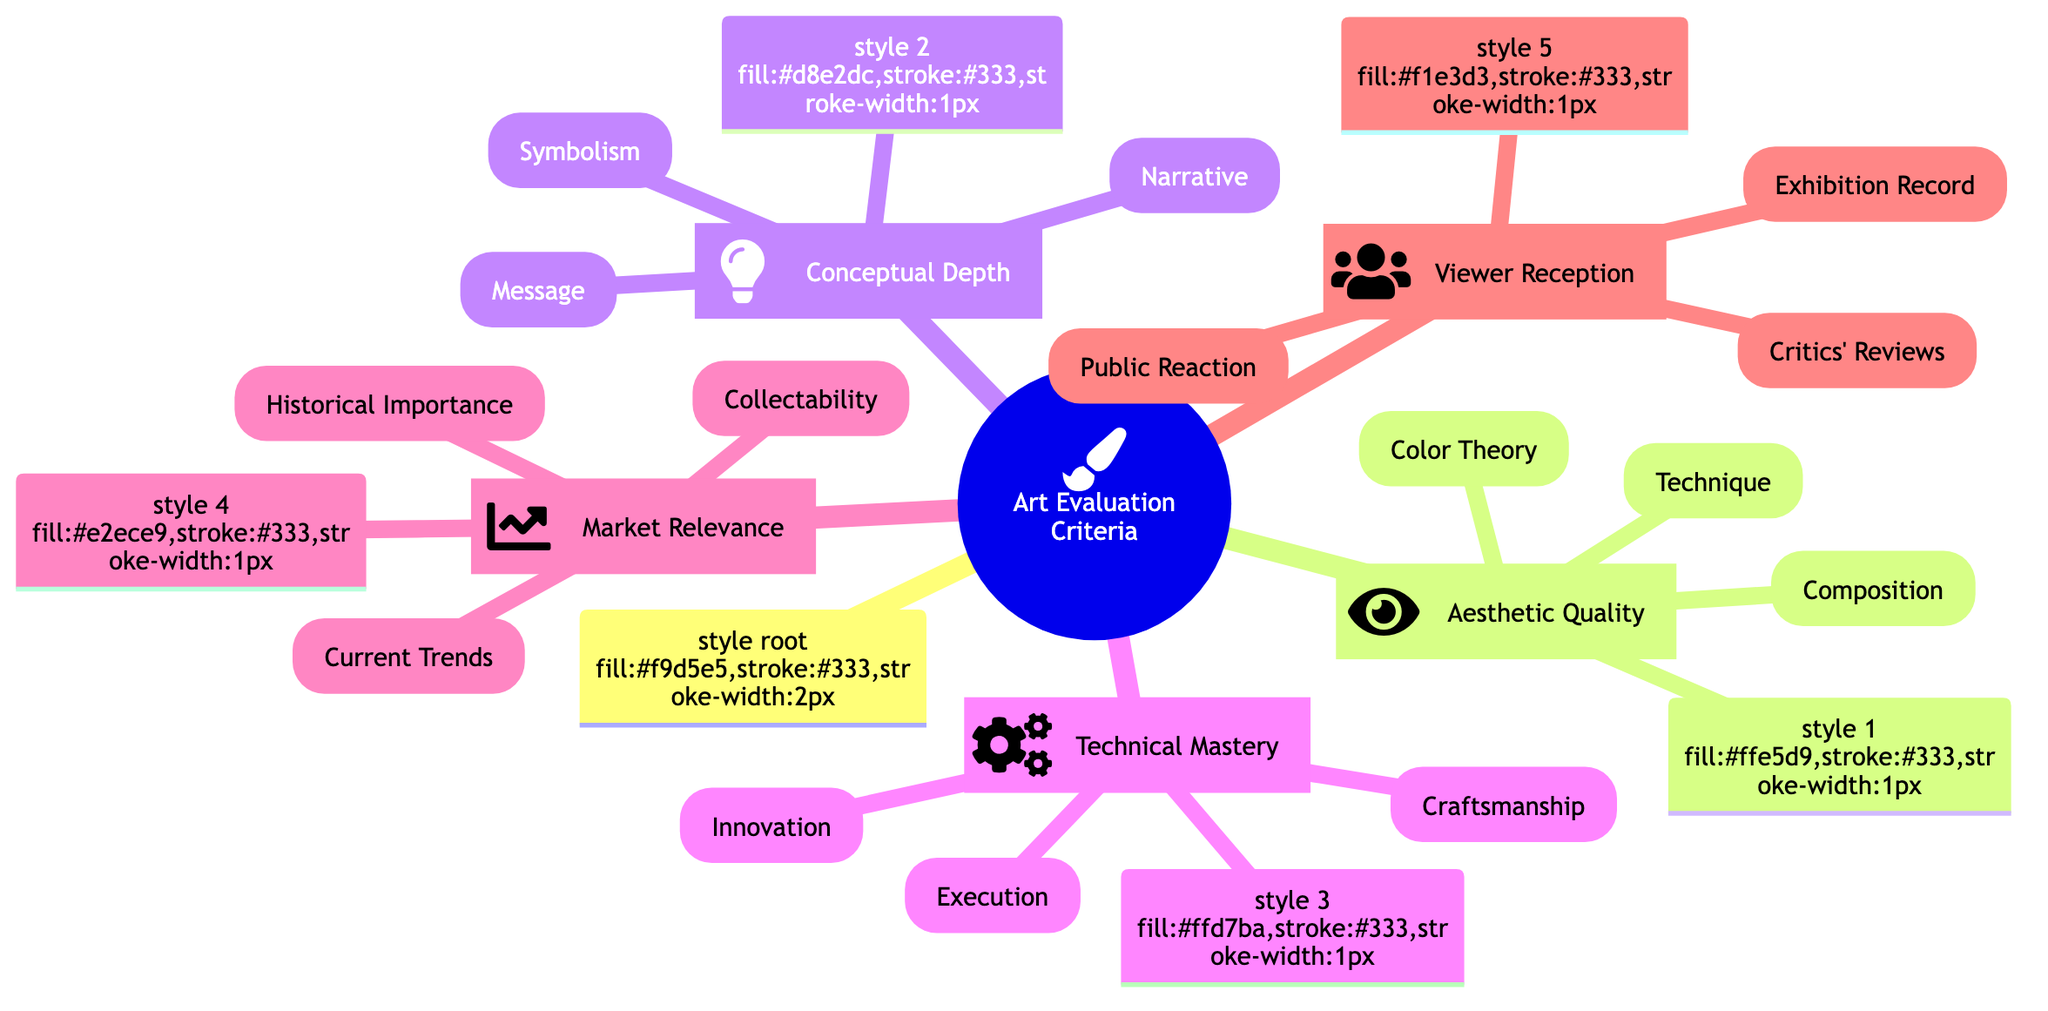What are the three main categories of Art Evaluation Criteria? The diagram has a root category "Art Evaluation Criteria," which branches into four distinct categories: Aesthetic Quality, Conceptual Depth, Technical Mastery, Market Relevance, and Viewer Reception.
Answer: Aesthetic Quality, Conceptual Depth, Technical Mastery, Market Relevance, Viewer Reception How many aspects are included under Technical Mastery? Under the category Technical Mastery, there are three aspects listed: Craftsmanship, Innovation, and Execution, which can be counted directly from the diagram.
Answer: 3 What is one key element of Aesthetic Quality? The diagram indicates that Aesthetic Quality includes several elements such as Composition, Color Theory, and Technique, any of which would answer this question.
Answer: Composition Which category directly involves public opinion in art evaluation? The category Viewer Reception focuses explicitly on public opinion, as indicated by the aspects listed under it, like Public Reaction and Critics' Reviews, emphasizing audience engagement.
Answer: Viewer Reception Which key element under Conceptual Depth deals with Art's social impact? The aspect Message under Conceptual Depth contains terms such as Social Commentary and Political Statements, directly reflecting the art's social impact.
Answer: Message What is the relationship between Technical Mastery and Market Relevance? Technical Mastery and Market Relevance are both primary categories of Art Evaluation Criteria, indicating they are equally important but focus on different evaluation aspects without a direct sub-relationship.
Answer: Parallel categories How many sub-aspects are listed under Market Relevance? The Market Relevance category includes three sub-aspects: Current Trends, Historical Importance, and Collectability, which can be directly verified in the diagram.
Answer: 3 Which aspect under Viewer Reception evaluates the artist's community impact? The aspect Public Reaction under Viewer Reception evaluates how the community responds to art, which includes audience engagement and emotional impact.
Answer: Public Reaction What differentiates Innovation from Craftsmanship in Technical Mastery? Innovation focuses on the originality and uniqueness of art while Craftsmanship emphasizes skill and precision in execution. Both are distinct aspects within Technical Mastery, showing different evaluation criteria.
Answer: Originality and uniqueness vs. precision and skill 